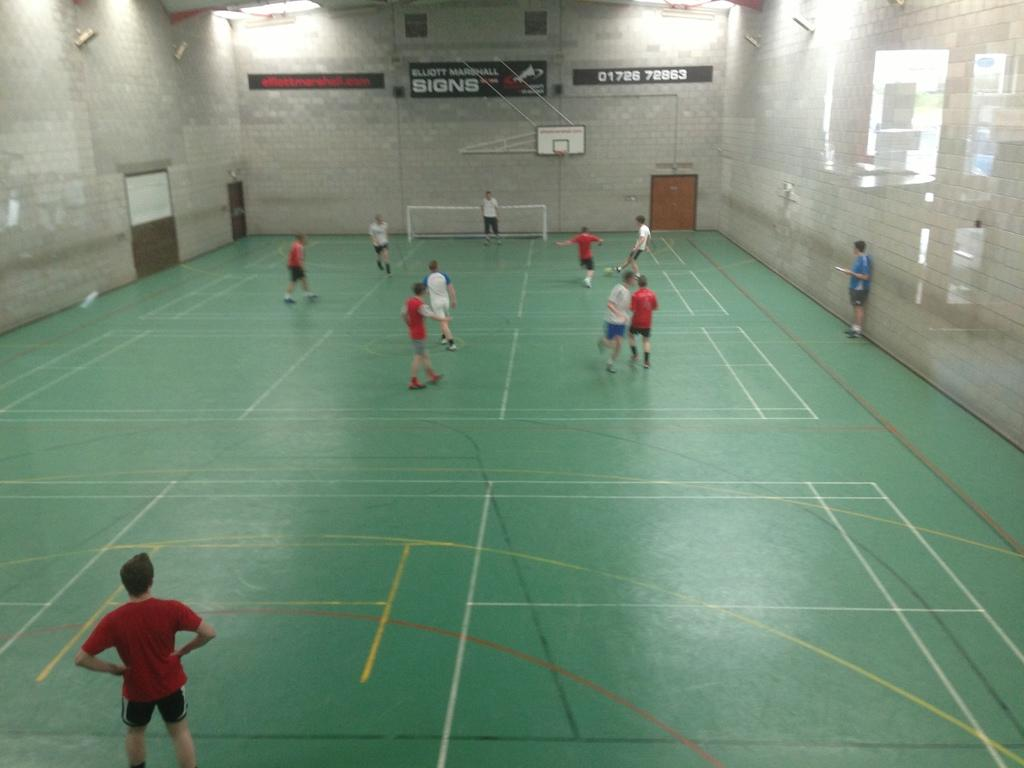Provide a one-sentence caption for the provided image. People play soccer on an indoor court with a Elliott Marshall Signs banner on the wall. 